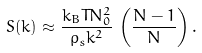<formula> <loc_0><loc_0><loc_500><loc_500>S ( k ) \approx \frac { k _ { B } T N ^ { 2 } _ { 0 } } { \rho _ { s } k ^ { 2 } } \, \left ( \frac { N - 1 } { N } \right ) .</formula> 